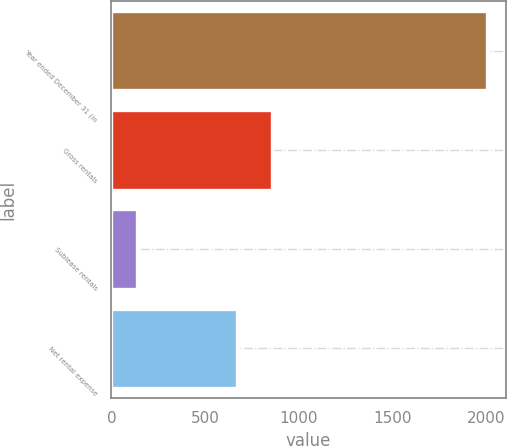<chart> <loc_0><loc_0><loc_500><loc_500><bar_chart><fcel>Year ended December 31 (in<fcel>Gross rentals<fcel>Sublease rentals<fcel>Net rental expense<nl><fcel>2001<fcel>855.6<fcel>135<fcel>669<nl></chart> 